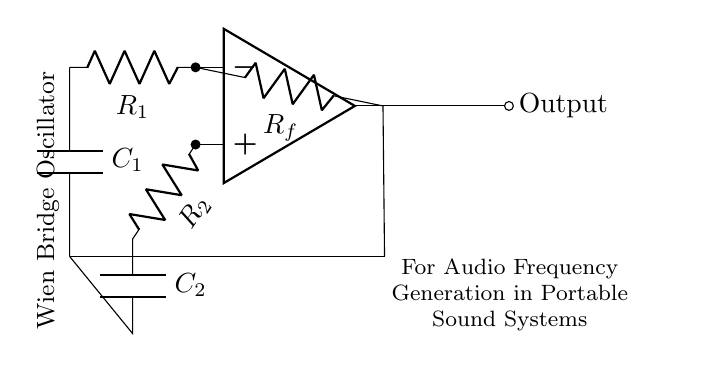What is the type of oscillator depicted in the diagram? The circuit is labeled as a Wien Bridge Oscillator, which is specifically designed for generating audio frequencies. The label and the description in the diagram clearly indicate this type of oscillator.
Answer: Wien Bridge Oscillator How many resistors are present in the circuit? The circuit diagram shows three resistors: R1, R2, and Rf. These components can be easily counted in the visual representation of the circuit.
Answer: Three What is the role of the capacitor in this oscillator circuit? The capacitors C1 and C2 are integral to the frequency determination in the Wien Bridge Oscillator. They are used in conjunction with the resistors to create a feedback loop that determines the oscillation frequency. This role is indicated by their connections to the op-amp and resistors in the circuit.
Answer: Frequency determination Which component is responsible for feedback in the circuit? The feedback is provided by the resistor Rf, which connects the output of the op-amp back to its inverting input. This is a critical aspect of the oscillator's operation, as it allows for the necessary conditions for oscillation to occur.
Answer: Rf What is the output of this oscillator circuit? The output of the circuit is indicated by the label at the right end of the circuit, which states "Output." This signal can be utilized for audio applications in portable sound systems, as mentioned in the diagram’s description.
Answer: Output How does the Wien Bridge Oscillator generate an audio frequency? The oscillator generates audio frequencies through a combination of resistors and capacitors that create a feedback loop with a specific gain condition. The precise relationship between R1, R2, C1, and C2 allows the circuit to oscillate at a frequency defined by these components. This is a fundamental concept in the functioning of this type of oscillator and is derived from the way the components are interconnected.
Answer: Through feedback loop 